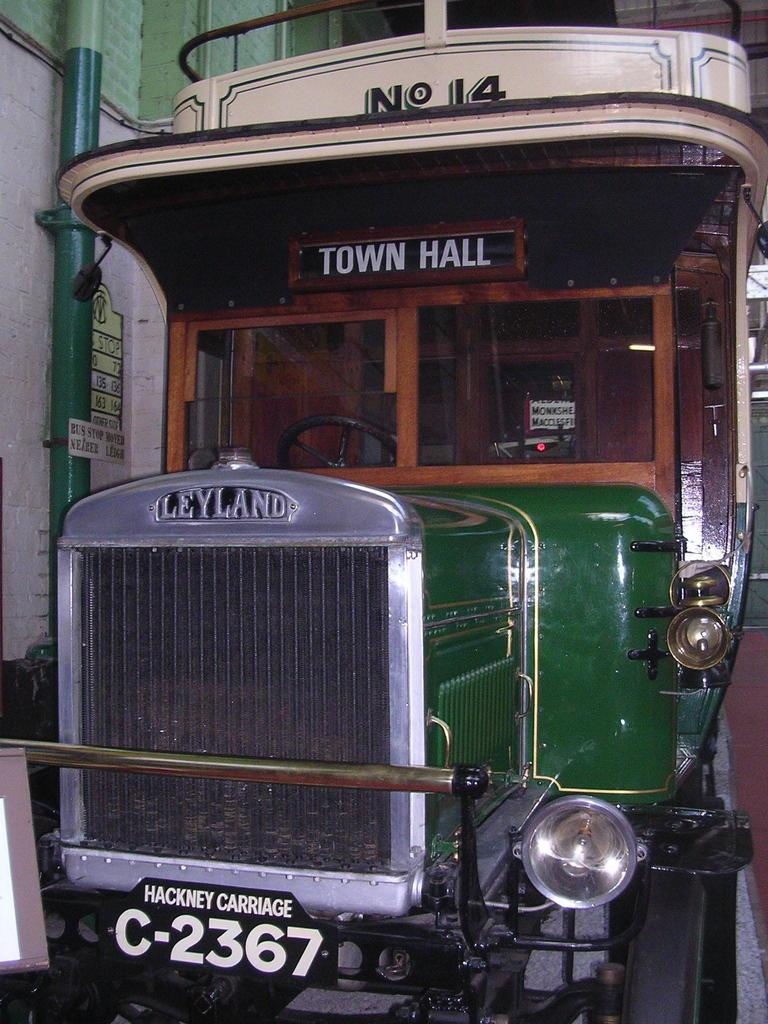What is the main subject of the image? There is a vehicle in the image. What can be seen on the right side of the image? There is a platform on the right side of the image. What is attached to a wall on the left side of the image? There is a pole attached to a wall on the left side of the image. What is attached to the vehicle in the image? Name boards are attached to the vehicle. What type of produce is hanging from the pole in the image? There is no produce present in the image; the pole is attached to a wall without any produce hanging from it. 